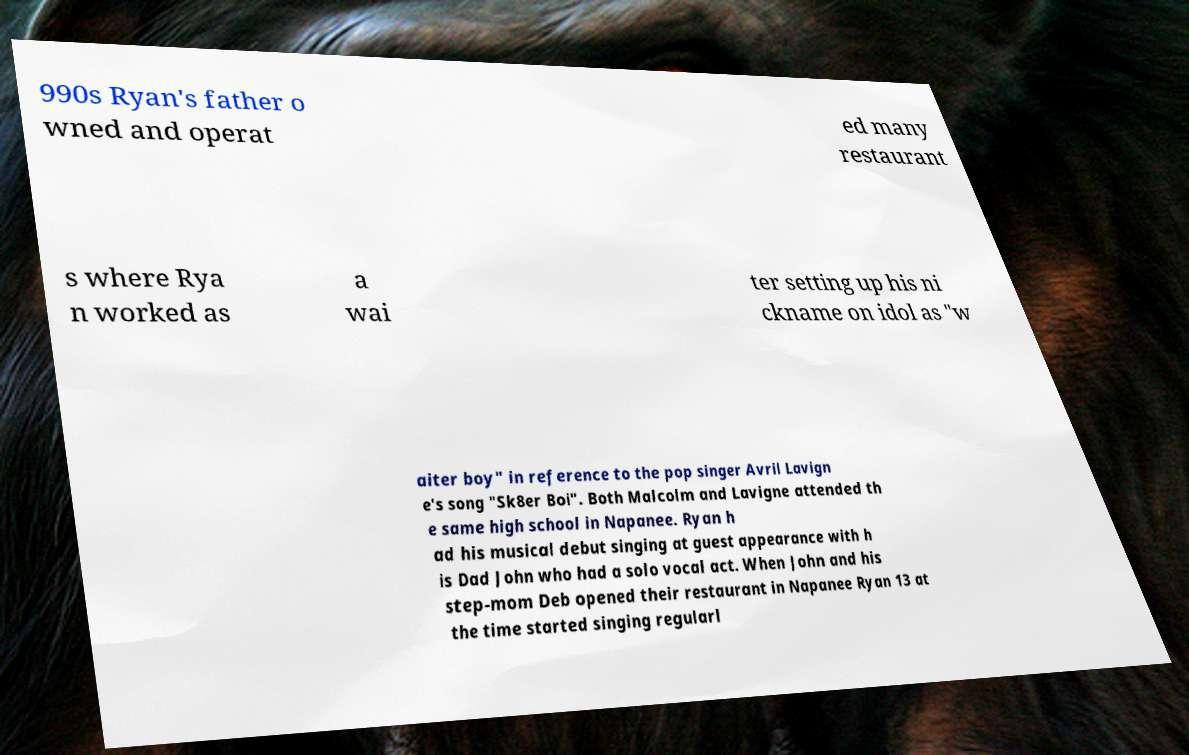I need the written content from this picture converted into text. Can you do that? 990s Ryan's father o wned and operat ed many restaurant s where Rya n worked as a wai ter setting up his ni ckname on idol as "w aiter boy" in reference to the pop singer Avril Lavign e's song "Sk8er Boi". Both Malcolm and Lavigne attended th e same high school in Napanee. Ryan h ad his musical debut singing at guest appearance with h is Dad John who had a solo vocal act. When John and his step-mom Deb opened their restaurant in Napanee Ryan 13 at the time started singing regularl 